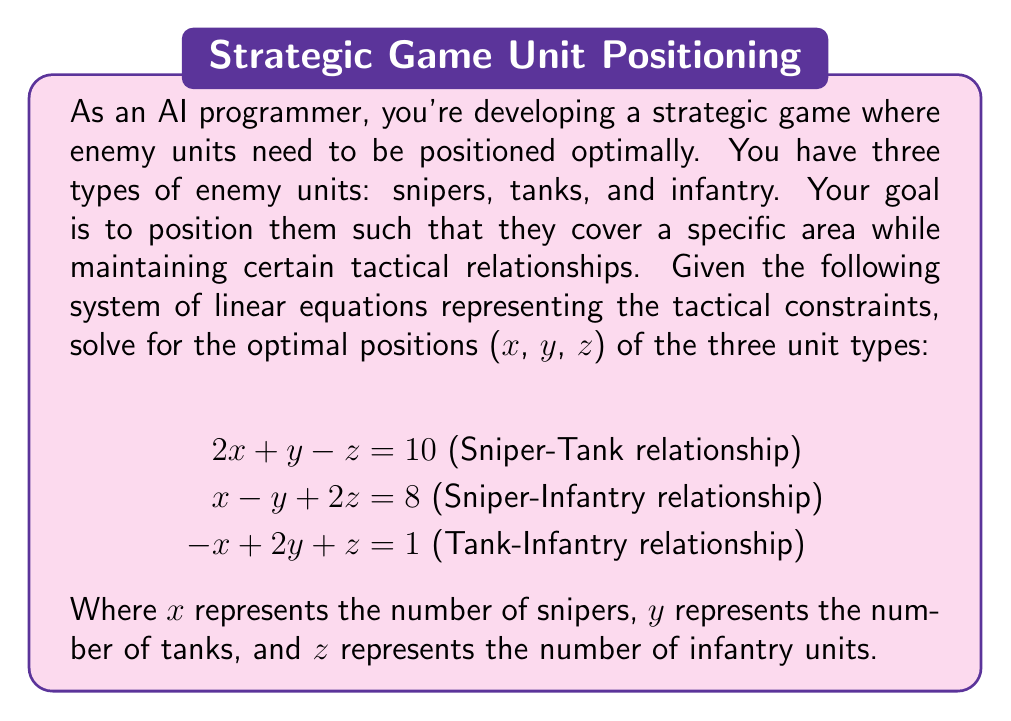Show me your answer to this math problem. To solve this system of linear equations, we'll use the elimination method:

1) First, let's eliminate x by adding equation (1) and equation (2):

   $$\begin{align}
   2x + y - z &= 10\\
   x - y + 2z &= 8\\
   \hline
   3x + z &= 18 \text{ (Equation 4)}
   \end{align}$$

2) Now, let's eliminate x by adding equation (1) and equation (3):

   $$\begin{align}
   2x + y - z &= 10\\
   -x + 2y + z &= 1\\
   \hline
   x + 3y &= 11 \text{ (Equation 5)}
   \end{align}$$

3) We now have a system of three equations:

   $$\begin{align}
   3x + z &= 18 \text{ (Equation 4)}\\
   x + 3y &= 11 \text{ (Equation 5)}\\
   -x + 2y + z &= 1 \text{ (Equation 3)}
   \end{align}$$

4) Multiply equation (5) by 3 and subtract it from equation (4) multiplied by 1:

   $$\begin{align}
   3x + z &= 18\\
   3x + 9y &= 33\\
   \hline
   z - 9y &= -15 \text{ (Equation 6)}
   \end{align}$$

5) Now, add equation (3) and equation (5):

   $$\begin{align}
   x + 3y &= 11\\
   -x + 2y + z &= 1\\
   \hline
   5y + z &= 12 \text{ (Equation 7)}
   \end{align}$$

6) Subtract equation (6) from equation (7):

   $$\begin{align}
   5y + z &= 12\\
   -9y + z &= -15\\
   \hline
   14y &= 27
   \end{align}$$

   Solving for y: $y = \frac{27}{14} = \frac{27}{14}$

7) Substitute y into equation (6):

   $z - 9(\frac{27}{14}) = -15$
   $z = -15 + \frac{243}{14} = \frac{33}{14}$

8) Substitute y and z into equation (5):

   $x + 3(\frac{27}{14}) = 11$
   $x = 11 - \frac{81}{14} = \frac{73}{14}$

Therefore, the optimal positions are:
$x = \frac{73}{14}$ (snipers)
$y = \frac{27}{14}$ (tanks)
$z = \frac{33}{14}$ (infantry)
Answer: The optimal positions for the enemy units are:
Snipers (x): $\frac{73}{14} \approx 5.21$
Tanks (y): $\frac{27}{14} \approx 1.93$
Infantry (z): $\frac{33}{14} \approx 2.36$ 